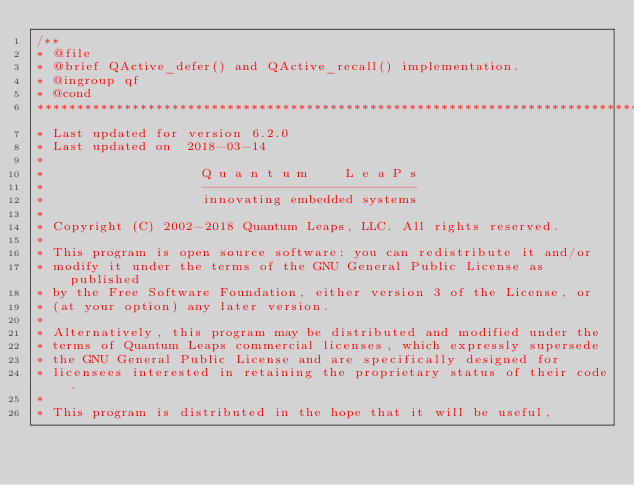<code> <loc_0><loc_0><loc_500><loc_500><_C_>/**
* @file
* @brief QActive_defer() and QActive_recall() implementation.
* @ingroup qf
* @cond
******************************************************************************
* Last updated for version 6.2.0
* Last updated on  2018-03-14
*
*                    Q u a n t u m     L e a P s
*                    ---------------------------
*                    innovating embedded systems
*
* Copyright (C) 2002-2018 Quantum Leaps, LLC. All rights reserved.
*
* This program is open source software: you can redistribute it and/or
* modify it under the terms of the GNU General Public License as published
* by the Free Software Foundation, either version 3 of the License, or
* (at your option) any later version.
*
* Alternatively, this program may be distributed and modified under the
* terms of Quantum Leaps commercial licenses, which expressly supersede
* the GNU General Public License and are specifically designed for
* licensees interested in retaining the proprietary status of their code.
*
* This program is distributed in the hope that it will be useful,</code> 